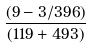<formula> <loc_0><loc_0><loc_500><loc_500>\frac { ( 9 - 3 / 3 9 6 ) } { ( 1 1 9 + 4 9 3 ) }</formula> 